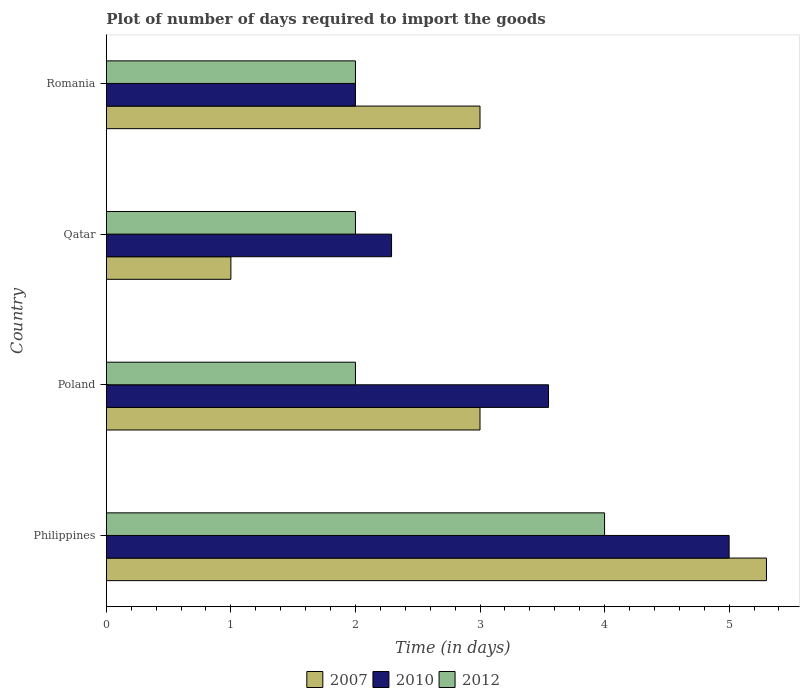How many different coloured bars are there?
Offer a terse response. 3. Are the number of bars per tick equal to the number of legend labels?
Provide a succinct answer. Yes. Are the number of bars on each tick of the Y-axis equal?
Make the answer very short. Yes. What is the label of the 2nd group of bars from the top?
Give a very brief answer. Qatar. What is the time required to import goods in 2012 in Qatar?
Ensure brevity in your answer.  2. Across all countries, what is the maximum time required to import goods in 2010?
Provide a short and direct response. 5. Across all countries, what is the minimum time required to import goods in 2010?
Your answer should be compact. 2. In which country was the time required to import goods in 2012 maximum?
Provide a short and direct response. Philippines. In which country was the time required to import goods in 2007 minimum?
Provide a succinct answer. Qatar. What is the difference between the time required to import goods in 2010 in Philippines and that in Poland?
Provide a short and direct response. 1.45. What is the difference between the time required to import goods in 2007 in Romania and the time required to import goods in 2010 in Philippines?
Ensure brevity in your answer.  -2. What is the average time required to import goods in 2010 per country?
Provide a short and direct response. 3.21. What is the difference between the time required to import goods in 2010 and time required to import goods in 2007 in Poland?
Ensure brevity in your answer.  0.55. In how many countries, is the time required to import goods in 2007 greater than 4.6 days?
Give a very brief answer. 1. What is the difference between the highest and the second highest time required to import goods in 2007?
Offer a very short reply. 2.3. In how many countries, is the time required to import goods in 2012 greater than the average time required to import goods in 2012 taken over all countries?
Offer a terse response. 1. Does the graph contain any zero values?
Offer a very short reply. No. Where does the legend appear in the graph?
Your response must be concise. Bottom center. What is the title of the graph?
Your answer should be very brief. Plot of number of days required to import the goods. What is the label or title of the X-axis?
Give a very brief answer. Time (in days). What is the Time (in days) of 2010 in Philippines?
Your answer should be very brief. 5. What is the Time (in days) in 2007 in Poland?
Your response must be concise. 3. What is the Time (in days) in 2010 in Poland?
Your answer should be compact. 3.55. What is the Time (in days) of 2010 in Qatar?
Offer a very short reply. 2.29. What is the Time (in days) in 2012 in Qatar?
Offer a terse response. 2. What is the Time (in days) of 2007 in Romania?
Ensure brevity in your answer.  3. What is the Time (in days) of 2010 in Romania?
Offer a terse response. 2. What is the Time (in days) of 2012 in Romania?
Offer a terse response. 2. Across all countries, what is the maximum Time (in days) of 2007?
Give a very brief answer. 5.3. Across all countries, what is the maximum Time (in days) in 2010?
Keep it short and to the point. 5. Across all countries, what is the minimum Time (in days) in 2012?
Give a very brief answer. 2. What is the total Time (in days) of 2010 in the graph?
Keep it short and to the point. 12.84. What is the total Time (in days) of 2012 in the graph?
Your answer should be compact. 10. What is the difference between the Time (in days) in 2007 in Philippines and that in Poland?
Your response must be concise. 2.3. What is the difference between the Time (in days) of 2010 in Philippines and that in Poland?
Your response must be concise. 1.45. What is the difference between the Time (in days) of 2007 in Philippines and that in Qatar?
Provide a short and direct response. 4.3. What is the difference between the Time (in days) in 2010 in Philippines and that in Qatar?
Keep it short and to the point. 2.71. What is the difference between the Time (in days) in 2012 in Philippines and that in Qatar?
Make the answer very short. 2. What is the difference between the Time (in days) in 2010 in Philippines and that in Romania?
Provide a succinct answer. 3. What is the difference between the Time (in days) in 2007 in Poland and that in Qatar?
Your answer should be very brief. 2. What is the difference between the Time (in days) of 2010 in Poland and that in Qatar?
Provide a short and direct response. 1.26. What is the difference between the Time (in days) in 2012 in Poland and that in Qatar?
Offer a very short reply. 0. What is the difference between the Time (in days) in 2010 in Poland and that in Romania?
Provide a short and direct response. 1.55. What is the difference between the Time (in days) in 2010 in Qatar and that in Romania?
Your response must be concise. 0.29. What is the difference between the Time (in days) in 2012 in Qatar and that in Romania?
Offer a very short reply. 0. What is the difference between the Time (in days) in 2007 in Philippines and the Time (in days) in 2010 in Poland?
Provide a short and direct response. 1.75. What is the difference between the Time (in days) of 2010 in Philippines and the Time (in days) of 2012 in Poland?
Make the answer very short. 3. What is the difference between the Time (in days) in 2007 in Philippines and the Time (in days) in 2010 in Qatar?
Keep it short and to the point. 3.01. What is the difference between the Time (in days) of 2007 in Poland and the Time (in days) of 2010 in Qatar?
Offer a very short reply. 0.71. What is the difference between the Time (in days) in 2010 in Poland and the Time (in days) in 2012 in Qatar?
Offer a very short reply. 1.55. What is the difference between the Time (in days) in 2007 in Poland and the Time (in days) in 2012 in Romania?
Make the answer very short. 1. What is the difference between the Time (in days) of 2010 in Poland and the Time (in days) of 2012 in Romania?
Offer a terse response. 1.55. What is the difference between the Time (in days) in 2007 in Qatar and the Time (in days) in 2012 in Romania?
Your answer should be very brief. -1. What is the difference between the Time (in days) in 2010 in Qatar and the Time (in days) in 2012 in Romania?
Your answer should be compact. 0.29. What is the average Time (in days) in 2007 per country?
Provide a short and direct response. 3.08. What is the average Time (in days) in 2010 per country?
Provide a succinct answer. 3.21. What is the difference between the Time (in days) in 2007 and Time (in days) in 2012 in Philippines?
Ensure brevity in your answer.  1.3. What is the difference between the Time (in days) in 2007 and Time (in days) in 2010 in Poland?
Provide a short and direct response. -0.55. What is the difference between the Time (in days) in 2007 and Time (in days) in 2012 in Poland?
Your response must be concise. 1. What is the difference between the Time (in days) of 2010 and Time (in days) of 2012 in Poland?
Ensure brevity in your answer.  1.55. What is the difference between the Time (in days) in 2007 and Time (in days) in 2010 in Qatar?
Keep it short and to the point. -1.29. What is the difference between the Time (in days) in 2007 and Time (in days) in 2012 in Qatar?
Make the answer very short. -1. What is the difference between the Time (in days) in 2010 and Time (in days) in 2012 in Qatar?
Offer a terse response. 0.29. What is the difference between the Time (in days) of 2007 and Time (in days) of 2010 in Romania?
Offer a terse response. 1. What is the difference between the Time (in days) in 2007 and Time (in days) in 2012 in Romania?
Give a very brief answer. 1. What is the difference between the Time (in days) in 2010 and Time (in days) in 2012 in Romania?
Provide a succinct answer. 0. What is the ratio of the Time (in days) of 2007 in Philippines to that in Poland?
Your response must be concise. 1.77. What is the ratio of the Time (in days) in 2010 in Philippines to that in Poland?
Provide a short and direct response. 1.41. What is the ratio of the Time (in days) of 2012 in Philippines to that in Poland?
Keep it short and to the point. 2. What is the ratio of the Time (in days) in 2010 in Philippines to that in Qatar?
Your answer should be compact. 2.18. What is the ratio of the Time (in days) in 2012 in Philippines to that in Qatar?
Ensure brevity in your answer.  2. What is the ratio of the Time (in days) of 2007 in Philippines to that in Romania?
Offer a very short reply. 1.77. What is the ratio of the Time (in days) in 2012 in Philippines to that in Romania?
Give a very brief answer. 2. What is the ratio of the Time (in days) in 2007 in Poland to that in Qatar?
Your answer should be compact. 3. What is the ratio of the Time (in days) of 2010 in Poland to that in Qatar?
Provide a short and direct response. 1.55. What is the ratio of the Time (in days) in 2010 in Poland to that in Romania?
Your response must be concise. 1.77. What is the ratio of the Time (in days) in 2012 in Poland to that in Romania?
Offer a very short reply. 1. What is the ratio of the Time (in days) in 2010 in Qatar to that in Romania?
Provide a short and direct response. 1.15. What is the ratio of the Time (in days) of 2012 in Qatar to that in Romania?
Make the answer very short. 1. What is the difference between the highest and the second highest Time (in days) in 2007?
Offer a terse response. 2.3. What is the difference between the highest and the second highest Time (in days) of 2010?
Your answer should be very brief. 1.45. What is the difference between the highest and the second highest Time (in days) of 2012?
Provide a succinct answer. 2. What is the difference between the highest and the lowest Time (in days) of 2012?
Keep it short and to the point. 2. 